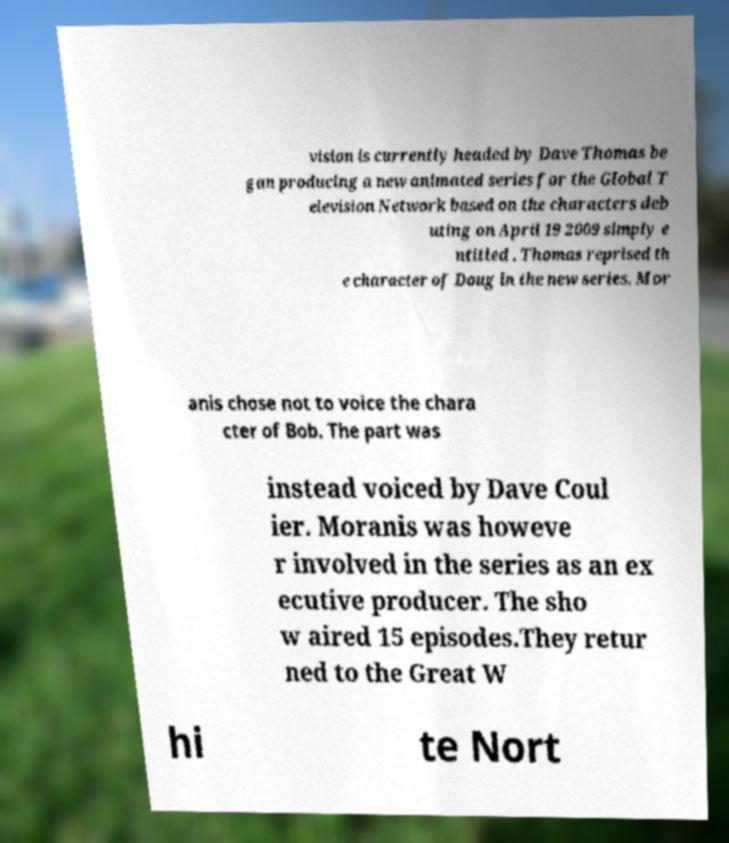Can you read and provide the text displayed in the image?This photo seems to have some interesting text. Can you extract and type it out for me? vision is currently headed by Dave Thomas be gan producing a new animated series for the Global T elevision Network based on the characters deb uting on April 19 2009 simply e ntitled . Thomas reprised th e character of Doug in the new series. Mor anis chose not to voice the chara cter of Bob. The part was instead voiced by Dave Coul ier. Moranis was howeve r involved in the series as an ex ecutive producer. The sho w aired 15 episodes.They retur ned to the Great W hi te Nort 